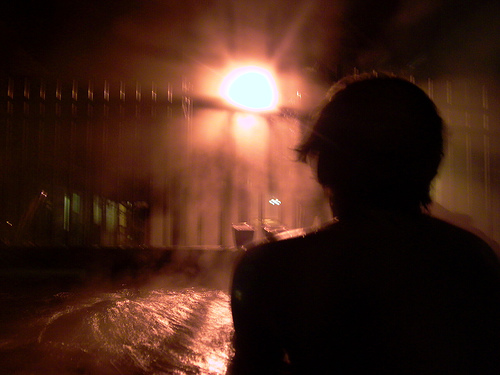<image>
Is there a light in front of the wall? No. The light is not in front of the wall. The spatial positioning shows a different relationship between these objects. 